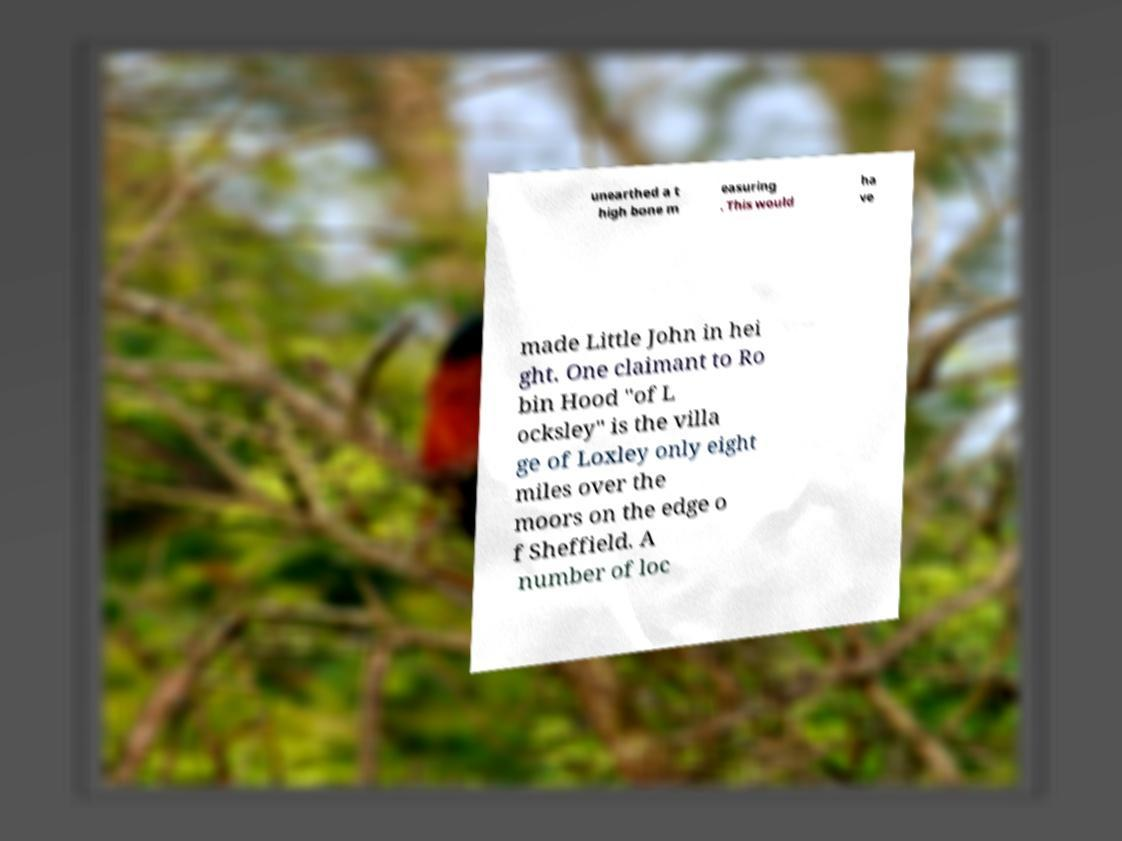I need the written content from this picture converted into text. Can you do that? unearthed a t high bone m easuring . This would ha ve made Little John in hei ght. One claimant to Ro bin Hood "of L ocksley" is the villa ge of Loxley only eight miles over the moors on the edge o f Sheffield. A number of loc 